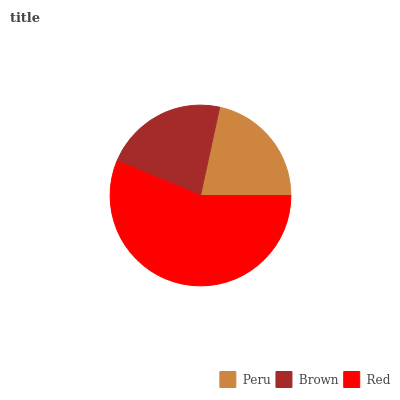Is Peru the minimum?
Answer yes or no. Yes. Is Red the maximum?
Answer yes or no. Yes. Is Brown the minimum?
Answer yes or no. No. Is Brown the maximum?
Answer yes or no. No. Is Brown greater than Peru?
Answer yes or no. Yes. Is Peru less than Brown?
Answer yes or no. Yes. Is Peru greater than Brown?
Answer yes or no. No. Is Brown less than Peru?
Answer yes or no. No. Is Brown the high median?
Answer yes or no. Yes. Is Brown the low median?
Answer yes or no. Yes. Is Red the high median?
Answer yes or no. No. Is Peru the low median?
Answer yes or no. No. 